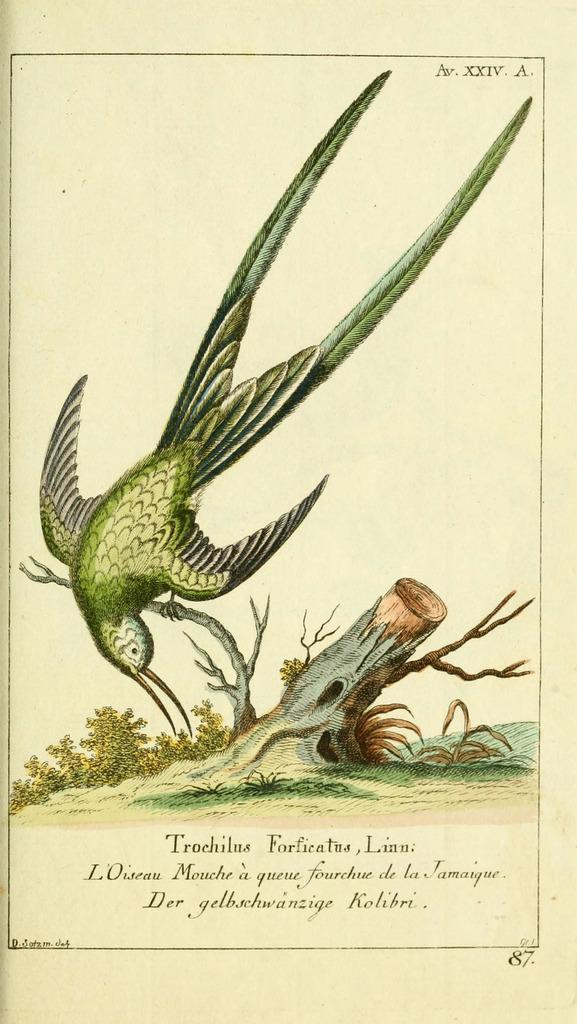What is depicted in the painting in the image? The painting contains a bird, a tree, and plants. What is the setting of the painting? The painting includes a tree and plants, suggesting a natural setting. Is there any text associated with the painting? Yes, there is text at the bottom of the image. What type of soap is being used to clean the bird in the painting? There is no soap or cleaning activity depicted in the painting; it features a bird in a natural setting with a tree and plants. 